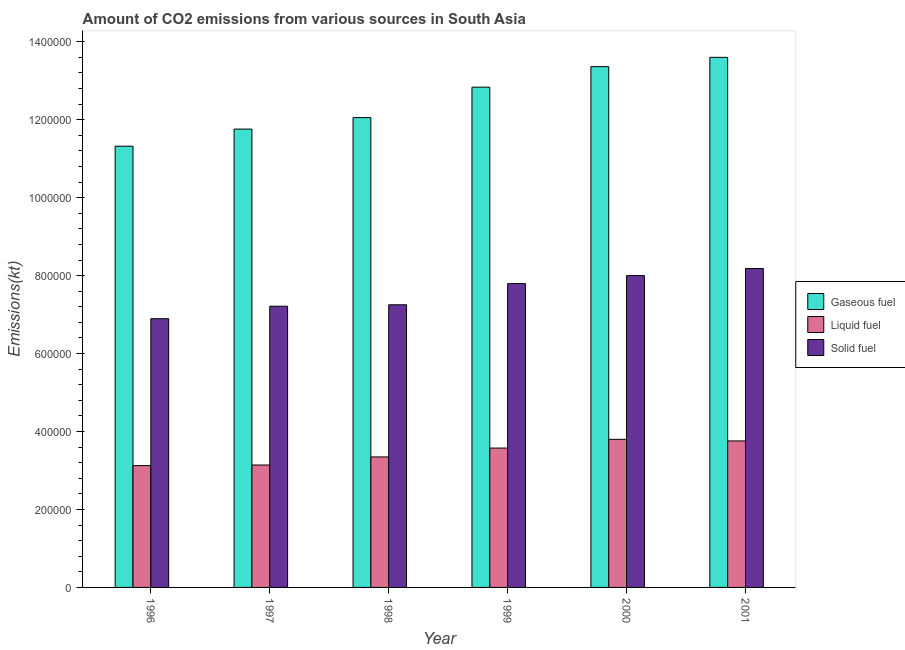How many different coloured bars are there?
Provide a short and direct response. 3. How many groups of bars are there?
Your response must be concise. 6. Are the number of bars on each tick of the X-axis equal?
Ensure brevity in your answer.  Yes. How many bars are there on the 4th tick from the left?
Your answer should be very brief. 3. How many bars are there on the 6th tick from the right?
Offer a very short reply. 3. What is the amount of co2 emissions from solid fuel in 1996?
Ensure brevity in your answer.  6.90e+05. Across all years, what is the maximum amount of co2 emissions from solid fuel?
Make the answer very short. 8.18e+05. Across all years, what is the minimum amount of co2 emissions from solid fuel?
Provide a succinct answer. 6.90e+05. In which year was the amount of co2 emissions from gaseous fuel maximum?
Offer a very short reply. 2001. What is the total amount of co2 emissions from solid fuel in the graph?
Offer a terse response. 4.53e+06. What is the difference between the amount of co2 emissions from liquid fuel in 1996 and that in 2001?
Keep it short and to the point. -6.33e+04. What is the difference between the amount of co2 emissions from solid fuel in 2001 and the amount of co2 emissions from gaseous fuel in 1998?
Ensure brevity in your answer.  9.31e+04. What is the average amount of co2 emissions from solid fuel per year?
Offer a terse response. 7.56e+05. What is the ratio of the amount of co2 emissions from solid fuel in 1996 to that in 1997?
Keep it short and to the point. 0.96. Is the amount of co2 emissions from solid fuel in 1997 less than that in 1999?
Offer a terse response. Yes. Is the difference between the amount of co2 emissions from gaseous fuel in 1998 and 1999 greater than the difference between the amount of co2 emissions from solid fuel in 1998 and 1999?
Keep it short and to the point. No. What is the difference between the highest and the second highest amount of co2 emissions from liquid fuel?
Provide a short and direct response. 4092.37. What is the difference between the highest and the lowest amount of co2 emissions from solid fuel?
Your response must be concise. 1.29e+05. What does the 2nd bar from the left in 1997 represents?
Your response must be concise. Liquid fuel. What does the 2nd bar from the right in 1996 represents?
Your answer should be compact. Liquid fuel. How many years are there in the graph?
Keep it short and to the point. 6. Does the graph contain any zero values?
Provide a succinct answer. No. Does the graph contain grids?
Provide a succinct answer. No. Where does the legend appear in the graph?
Your answer should be compact. Center right. How are the legend labels stacked?
Keep it short and to the point. Vertical. What is the title of the graph?
Provide a succinct answer. Amount of CO2 emissions from various sources in South Asia. Does "Ages 20-50" appear as one of the legend labels in the graph?
Provide a succinct answer. No. What is the label or title of the Y-axis?
Offer a very short reply. Emissions(kt). What is the Emissions(kt) in Gaseous fuel in 1996?
Your answer should be very brief. 1.13e+06. What is the Emissions(kt) of Liquid fuel in 1996?
Provide a succinct answer. 3.13e+05. What is the Emissions(kt) in Solid fuel in 1996?
Offer a terse response. 6.90e+05. What is the Emissions(kt) of Gaseous fuel in 1997?
Offer a terse response. 1.18e+06. What is the Emissions(kt) in Liquid fuel in 1997?
Offer a very short reply. 3.14e+05. What is the Emissions(kt) of Solid fuel in 1997?
Ensure brevity in your answer.  7.22e+05. What is the Emissions(kt) in Gaseous fuel in 1998?
Make the answer very short. 1.21e+06. What is the Emissions(kt) of Liquid fuel in 1998?
Your response must be concise. 3.35e+05. What is the Emissions(kt) of Solid fuel in 1998?
Provide a succinct answer. 7.25e+05. What is the Emissions(kt) of Gaseous fuel in 1999?
Offer a terse response. 1.28e+06. What is the Emissions(kt) in Liquid fuel in 1999?
Offer a terse response. 3.58e+05. What is the Emissions(kt) in Solid fuel in 1999?
Provide a succinct answer. 7.79e+05. What is the Emissions(kt) of Gaseous fuel in 2000?
Offer a very short reply. 1.34e+06. What is the Emissions(kt) of Liquid fuel in 2000?
Give a very brief answer. 3.80e+05. What is the Emissions(kt) of Solid fuel in 2000?
Provide a short and direct response. 8.00e+05. What is the Emissions(kt) of Gaseous fuel in 2001?
Provide a succinct answer. 1.36e+06. What is the Emissions(kt) of Liquid fuel in 2001?
Your response must be concise. 3.76e+05. What is the Emissions(kt) in Solid fuel in 2001?
Make the answer very short. 8.18e+05. Across all years, what is the maximum Emissions(kt) in Gaseous fuel?
Your answer should be compact. 1.36e+06. Across all years, what is the maximum Emissions(kt) of Liquid fuel?
Your answer should be very brief. 3.80e+05. Across all years, what is the maximum Emissions(kt) of Solid fuel?
Your answer should be very brief. 8.18e+05. Across all years, what is the minimum Emissions(kt) in Gaseous fuel?
Give a very brief answer. 1.13e+06. Across all years, what is the minimum Emissions(kt) of Liquid fuel?
Provide a succinct answer. 3.13e+05. Across all years, what is the minimum Emissions(kt) of Solid fuel?
Your answer should be very brief. 6.90e+05. What is the total Emissions(kt) of Gaseous fuel in the graph?
Provide a succinct answer. 7.49e+06. What is the total Emissions(kt) of Liquid fuel in the graph?
Offer a terse response. 2.07e+06. What is the total Emissions(kt) of Solid fuel in the graph?
Your answer should be compact. 4.53e+06. What is the difference between the Emissions(kt) of Gaseous fuel in 1996 and that in 1997?
Ensure brevity in your answer.  -4.39e+04. What is the difference between the Emissions(kt) in Liquid fuel in 1996 and that in 1997?
Your answer should be very brief. -1547.47. What is the difference between the Emissions(kt) in Solid fuel in 1996 and that in 1997?
Make the answer very short. -3.20e+04. What is the difference between the Emissions(kt) in Gaseous fuel in 1996 and that in 1998?
Keep it short and to the point. -7.34e+04. What is the difference between the Emissions(kt) of Liquid fuel in 1996 and that in 1998?
Provide a succinct answer. -2.23e+04. What is the difference between the Emissions(kt) in Solid fuel in 1996 and that in 1998?
Your answer should be compact. -3.57e+04. What is the difference between the Emissions(kt) in Gaseous fuel in 1996 and that in 1999?
Provide a succinct answer. -1.51e+05. What is the difference between the Emissions(kt) in Liquid fuel in 1996 and that in 1999?
Offer a terse response. -4.50e+04. What is the difference between the Emissions(kt) in Solid fuel in 1996 and that in 1999?
Give a very brief answer. -9.00e+04. What is the difference between the Emissions(kt) in Gaseous fuel in 1996 and that in 2000?
Your answer should be very brief. -2.04e+05. What is the difference between the Emissions(kt) of Liquid fuel in 1996 and that in 2000?
Provide a succinct answer. -6.74e+04. What is the difference between the Emissions(kt) in Solid fuel in 1996 and that in 2000?
Give a very brief answer. -1.11e+05. What is the difference between the Emissions(kt) of Gaseous fuel in 1996 and that in 2001?
Your response must be concise. -2.28e+05. What is the difference between the Emissions(kt) of Liquid fuel in 1996 and that in 2001?
Your answer should be very brief. -6.33e+04. What is the difference between the Emissions(kt) in Solid fuel in 1996 and that in 2001?
Provide a succinct answer. -1.29e+05. What is the difference between the Emissions(kt) of Gaseous fuel in 1997 and that in 1998?
Offer a terse response. -2.95e+04. What is the difference between the Emissions(kt) of Liquid fuel in 1997 and that in 1998?
Provide a succinct answer. -2.07e+04. What is the difference between the Emissions(kt) of Solid fuel in 1997 and that in 1998?
Offer a terse response. -3677.84. What is the difference between the Emissions(kt) in Gaseous fuel in 1997 and that in 1999?
Your response must be concise. -1.08e+05. What is the difference between the Emissions(kt) in Liquid fuel in 1997 and that in 1999?
Your answer should be very brief. -4.35e+04. What is the difference between the Emissions(kt) in Solid fuel in 1997 and that in 1999?
Keep it short and to the point. -5.80e+04. What is the difference between the Emissions(kt) of Gaseous fuel in 1997 and that in 2000?
Your answer should be compact. -1.60e+05. What is the difference between the Emissions(kt) in Liquid fuel in 1997 and that in 2000?
Make the answer very short. -6.59e+04. What is the difference between the Emissions(kt) of Solid fuel in 1997 and that in 2000?
Make the answer very short. -7.85e+04. What is the difference between the Emissions(kt) in Gaseous fuel in 1997 and that in 2001?
Provide a succinct answer. -1.84e+05. What is the difference between the Emissions(kt) of Liquid fuel in 1997 and that in 2001?
Provide a short and direct response. -6.18e+04. What is the difference between the Emissions(kt) in Solid fuel in 1997 and that in 2001?
Give a very brief answer. -9.68e+04. What is the difference between the Emissions(kt) in Gaseous fuel in 1998 and that in 1999?
Ensure brevity in your answer.  -7.81e+04. What is the difference between the Emissions(kt) in Liquid fuel in 1998 and that in 1999?
Offer a terse response. -2.27e+04. What is the difference between the Emissions(kt) of Solid fuel in 1998 and that in 1999?
Give a very brief answer. -5.43e+04. What is the difference between the Emissions(kt) of Gaseous fuel in 1998 and that in 2000?
Ensure brevity in your answer.  -1.31e+05. What is the difference between the Emissions(kt) in Liquid fuel in 1998 and that in 2000?
Make the answer very short. -4.51e+04. What is the difference between the Emissions(kt) in Solid fuel in 1998 and that in 2000?
Keep it short and to the point. -7.49e+04. What is the difference between the Emissions(kt) in Gaseous fuel in 1998 and that in 2001?
Offer a very short reply. -1.55e+05. What is the difference between the Emissions(kt) of Liquid fuel in 1998 and that in 2001?
Ensure brevity in your answer.  -4.10e+04. What is the difference between the Emissions(kt) of Solid fuel in 1998 and that in 2001?
Your answer should be very brief. -9.31e+04. What is the difference between the Emissions(kt) in Gaseous fuel in 1999 and that in 2000?
Ensure brevity in your answer.  -5.26e+04. What is the difference between the Emissions(kt) in Liquid fuel in 1999 and that in 2000?
Your answer should be very brief. -2.24e+04. What is the difference between the Emissions(kt) of Solid fuel in 1999 and that in 2000?
Offer a very short reply. -2.06e+04. What is the difference between the Emissions(kt) of Gaseous fuel in 1999 and that in 2001?
Your answer should be very brief. -7.66e+04. What is the difference between the Emissions(kt) in Liquid fuel in 1999 and that in 2001?
Provide a short and direct response. -1.83e+04. What is the difference between the Emissions(kt) of Solid fuel in 1999 and that in 2001?
Provide a succinct answer. -3.88e+04. What is the difference between the Emissions(kt) in Gaseous fuel in 2000 and that in 2001?
Your answer should be very brief. -2.40e+04. What is the difference between the Emissions(kt) in Liquid fuel in 2000 and that in 2001?
Provide a succinct answer. 4092.37. What is the difference between the Emissions(kt) in Solid fuel in 2000 and that in 2001?
Offer a very short reply. -1.82e+04. What is the difference between the Emissions(kt) in Gaseous fuel in 1996 and the Emissions(kt) in Liquid fuel in 1997?
Provide a short and direct response. 8.18e+05. What is the difference between the Emissions(kt) in Gaseous fuel in 1996 and the Emissions(kt) in Solid fuel in 1997?
Give a very brief answer. 4.11e+05. What is the difference between the Emissions(kt) of Liquid fuel in 1996 and the Emissions(kt) of Solid fuel in 1997?
Keep it short and to the point. -4.09e+05. What is the difference between the Emissions(kt) in Gaseous fuel in 1996 and the Emissions(kt) in Liquid fuel in 1998?
Offer a terse response. 7.97e+05. What is the difference between the Emissions(kt) in Gaseous fuel in 1996 and the Emissions(kt) in Solid fuel in 1998?
Offer a very short reply. 4.07e+05. What is the difference between the Emissions(kt) of Liquid fuel in 1996 and the Emissions(kt) of Solid fuel in 1998?
Ensure brevity in your answer.  -4.13e+05. What is the difference between the Emissions(kt) of Gaseous fuel in 1996 and the Emissions(kt) of Liquid fuel in 1999?
Give a very brief answer. 7.75e+05. What is the difference between the Emissions(kt) in Gaseous fuel in 1996 and the Emissions(kt) in Solid fuel in 1999?
Give a very brief answer. 3.53e+05. What is the difference between the Emissions(kt) in Liquid fuel in 1996 and the Emissions(kt) in Solid fuel in 1999?
Offer a very short reply. -4.67e+05. What is the difference between the Emissions(kt) in Gaseous fuel in 1996 and the Emissions(kt) in Liquid fuel in 2000?
Offer a terse response. 7.52e+05. What is the difference between the Emissions(kt) of Gaseous fuel in 1996 and the Emissions(kt) of Solid fuel in 2000?
Offer a very short reply. 3.32e+05. What is the difference between the Emissions(kt) in Liquid fuel in 1996 and the Emissions(kt) in Solid fuel in 2000?
Make the answer very short. -4.88e+05. What is the difference between the Emissions(kt) in Gaseous fuel in 1996 and the Emissions(kt) in Liquid fuel in 2001?
Your answer should be very brief. 7.56e+05. What is the difference between the Emissions(kt) of Gaseous fuel in 1996 and the Emissions(kt) of Solid fuel in 2001?
Your answer should be very brief. 3.14e+05. What is the difference between the Emissions(kt) of Liquid fuel in 1996 and the Emissions(kt) of Solid fuel in 2001?
Provide a short and direct response. -5.06e+05. What is the difference between the Emissions(kt) of Gaseous fuel in 1997 and the Emissions(kt) of Liquid fuel in 1998?
Provide a short and direct response. 8.41e+05. What is the difference between the Emissions(kt) of Gaseous fuel in 1997 and the Emissions(kt) of Solid fuel in 1998?
Ensure brevity in your answer.  4.51e+05. What is the difference between the Emissions(kt) of Liquid fuel in 1997 and the Emissions(kt) of Solid fuel in 1998?
Provide a short and direct response. -4.11e+05. What is the difference between the Emissions(kt) in Gaseous fuel in 1997 and the Emissions(kt) in Liquid fuel in 1999?
Offer a terse response. 8.18e+05. What is the difference between the Emissions(kt) of Gaseous fuel in 1997 and the Emissions(kt) of Solid fuel in 1999?
Your answer should be very brief. 3.97e+05. What is the difference between the Emissions(kt) in Liquid fuel in 1997 and the Emissions(kt) in Solid fuel in 1999?
Your answer should be compact. -4.65e+05. What is the difference between the Emissions(kt) in Gaseous fuel in 1997 and the Emissions(kt) in Liquid fuel in 2000?
Your answer should be compact. 7.96e+05. What is the difference between the Emissions(kt) of Gaseous fuel in 1997 and the Emissions(kt) of Solid fuel in 2000?
Ensure brevity in your answer.  3.76e+05. What is the difference between the Emissions(kt) in Liquid fuel in 1997 and the Emissions(kt) in Solid fuel in 2000?
Provide a short and direct response. -4.86e+05. What is the difference between the Emissions(kt) of Gaseous fuel in 1997 and the Emissions(kt) of Liquid fuel in 2001?
Give a very brief answer. 8.00e+05. What is the difference between the Emissions(kt) in Gaseous fuel in 1997 and the Emissions(kt) in Solid fuel in 2001?
Your response must be concise. 3.58e+05. What is the difference between the Emissions(kt) of Liquid fuel in 1997 and the Emissions(kt) of Solid fuel in 2001?
Provide a succinct answer. -5.04e+05. What is the difference between the Emissions(kt) in Gaseous fuel in 1998 and the Emissions(kt) in Liquid fuel in 1999?
Make the answer very short. 8.48e+05. What is the difference between the Emissions(kt) in Gaseous fuel in 1998 and the Emissions(kt) in Solid fuel in 1999?
Your response must be concise. 4.26e+05. What is the difference between the Emissions(kt) in Liquid fuel in 1998 and the Emissions(kt) in Solid fuel in 1999?
Ensure brevity in your answer.  -4.45e+05. What is the difference between the Emissions(kt) in Gaseous fuel in 1998 and the Emissions(kt) in Liquid fuel in 2000?
Provide a succinct answer. 8.26e+05. What is the difference between the Emissions(kt) of Gaseous fuel in 1998 and the Emissions(kt) of Solid fuel in 2000?
Keep it short and to the point. 4.05e+05. What is the difference between the Emissions(kt) in Liquid fuel in 1998 and the Emissions(kt) in Solid fuel in 2000?
Your answer should be compact. -4.65e+05. What is the difference between the Emissions(kt) in Gaseous fuel in 1998 and the Emissions(kt) in Liquid fuel in 2001?
Provide a succinct answer. 8.30e+05. What is the difference between the Emissions(kt) in Gaseous fuel in 1998 and the Emissions(kt) in Solid fuel in 2001?
Keep it short and to the point. 3.87e+05. What is the difference between the Emissions(kt) in Liquid fuel in 1998 and the Emissions(kt) in Solid fuel in 2001?
Make the answer very short. -4.83e+05. What is the difference between the Emissions(kt) in Gaseous fuel in 1999 and the Emissions(kt) in Liquid fuel in 2000?
Your answer should be compact. 9.04e+05. What is the difference between the Emissions(kt) in Gaseous fuel in 1999 and the Emissions(kt) in Solid fuel in 2000?
Keep it short and to the point. 4.83e+05. What is the difference between the Emissions(kt) of Liquid fuel in 1999 and the Emissions(kt) of Solid fuel in 2000?
Offer a very short reply. -4.42e+05. What is the difference between the Emissions(kt) in Gaseous fuel in 1999 and the Emissions(kt) in Liquid fuel in 2001?
Give a very brief answer. 9.08e+05. What is the difference between the Emissions(kt) of Gaseous fuel in 1999 and the Emissions(kt) of Solid fuel in 2001?
Provide a short and direct response. 4.65e+05. What is the difference between the Emissions(kt) in Liquid fuel in 1999 and the Emissions(kt) in Solid fuel in 2001?
Your answer should be compact. -4.61e+05. What is the difference between the Emissions(kt) of Gaseous fuel in 2000 and the Emissions(kt) of Liquid fuel in 2001?
Offer a terse response. 9.60e+05. What is the difference between the Emissions(kt) in Gaseous fuel in 2000 and the Emissions(kt) in Solid fuel in 2001?
Keep it short and to the point. 5.18e+05. What is the difference between the Emissions(kt) of Liquid fuel in 2000 and the Emissions(kt) of Solid fuel in 2001?
Ensure brevity in your answer.  -4.38e+05. What is the average Emissions(kt) in Gaseous fuel per year?
Your answer should be compact. 1.25e+06. What is the average Emissions(kt) in Liquid fuel per year?
Offer a very short reply. 3.46e+05. What is the average Emissions(kt) of Solid fuel per year?
Give a very brief answer. 7.56e+05. In the year 1996, what is the difference between the Emissions(kt) of Gaseous fuel and Emissions(kt) of Liquid fuel?
Give a very brief answer. 8.20e+05. In the year 1996, what is the difference between the Emissions(kt) of Gaseous fuel and Emissions(kt) of Solid fuel?
Provide a short and direct response. 4.43e+05. In the year 1996, what is the difference between the Emissions(kt) of Liquid fuel and Emissions(kt) of Solid fuel?
Ensure brevity in your answer.  -3.77e+05. In the year 1997, what is the difference between the Emissions(kt) in Gaseous fuel and Emissions(kt) in Liquid fuel?
Make the answer very short. 8.62e+05. In the year 1997, what is the difference between the Emissions(kt) in Gaseous fuel and Emissions(kt) in Solid fuel?
Ensure brevity in your answer.  4.54e+05. In the year 1997, what is the difference between the Emissions(kt) in Liquid fuel and Emissions(kt) in Solid fuel?
Provide a succinct answer. -4.07e+05. In the year 1998, what is the difference between the Emissions(kt) in Gaseous fuel and Emissions(kt) in Liquid fuel?
Provide a succinct answer. 8.71e+05. In the year 1998, what is the difference between the Emissions(kt) in Gaseous fuel and Emissions(kt) in Solid fuel?
Make the answer very short. 4.80e+05. In the year 1998, what is the difference between the Emissions(kt) of Liquid fuel and Emissions(kt) of Solid fuel?
Offer a terse response. -3.90e+05. In the year 1999, what is the difference between the Emissions(kt) of Gaseous fuel and Emissions(kt) of Liquid fuel?
Give a very brief answer. 9.26e+05. In the year 1999, what is the difference between the Emissions(kt) of Gaseous fuel and Emissions(kt) of Solid fuel?
Your answer should be very brief. 5.04e+05. In the year 1999, what is the difference between the Emissions(kt) of Liquid fuel and Emissions(kt) of Solid fuel?
Ensure brevity in your answer.  -4.22e+05. In the year 2000, what is the difference between the Emissions(kt) of Gaseous fuel and Emissions(kt) of Liquid fuel?
Offer a terse response. 9.56e+05. In the year 2000, what is the difference between the Emissions(kt) of Gaseous fuel and Emissions(kt) of Solid fuel?
Provide a short and direct response. 5.36e+05. In the year 2000, what is the difference between the Emissions(kt) in Liquid fuel and Emissions(kt) in Solid fuel?
Provide a succinct answer. -4.20e+05. In the year 2001, what is the difference between the Emissions(kt) in Gaseous fuel and Emissions(kt) in Liquid fuel?
Offer a very short reply. 9.84e+05. In the year 2001, what is the difference between the Emissions(kt) in Gaseous fuel and Emissions(kt) in Solid fuel?
Your answer should be compact. 5.42e+05. In the year 2001, what is the difference between the Emissions(kt) in Liquid fuel and Emissions(kt) in Solid fuel?
Provide a succinct answer. -4.42e+05. What is the ratio of the Emissions(kt) of Gaseous fuel in 1996 to that in 1997?
Offer a terse response. 0.96. What is the ratio of the Emissions(kt) in Solid fuel in 1996 to that in 1997?
Keep it short and to the point. 0.96. What is the ratio of the Emissions(kt) in Gaseous fuel in 1996 to that in 1998?
Offer a terse response. 0.94. What is the ratio of the Emissions(kt) of Liquid fuel in 1996 to that in 1998?
Your answer should be compact. 0.93. What is the ratio of the Emissions(kt) of Solid fuel in 1996 to that in 1998?
Give a very brief answer. 0.95. What is the ratio of the Emissions(kt) in Gaseous fuel in 1996 to that in 1999?
Ensure brevity in your answer.  0.88. What is the ratio of the Emissions(kt) in Liquid fuel in 1996 to that in 1999?
Offer a very short reply. 0.87. What is the ratio of the Emissions(kt) of Solid fuel in 1996 to that in 1999?
Keep it short and to the point. 0.88. What is the ratio of the Emissions(kt) in Gaseous fuel in 1996 to that in 2000?
Provide a short and direct response. 0.85. What is the ratio of the Emissions(kt) of Liquid fuel in 1996 to that in 2000?
Your response must be concise. 0.82. What is the ratio of the Emissions(kt) in Solid fuel in 1996 to that in 2000?
Keep it short and to the point. 0.86. What is the ratio of the Emissions(kt) in Gaseous fuel in 1996 to that in 2001?
Offer a terse response. 0.83. What is the ratio of the Emissions(kt) in Liquid fuel in 1996 to that in 2001?
Your response must be concise. 0.83. What is the ratio of the Emissions(kt) in Solid fuel in 1996 to that in 2001?
Keep it short and to the point. 0.84. What is the ratio of the Emissions(kt) of Gaseous fuel in 1997 to that in 1998?
Make the answer very short. 0.98. What is the ratio of the Emissions(kt) of Liquid fuel in 1997 to that in 1998?
Provide a short and direct response. 0.94. What is the ratio of the Emissions(kt) of Solid fuel in 1997 to that in 1998?
Ensure brevity in your answer.  0.99. What is the ratio of the Emissions(kt) in Gaseous fuel in 1997 to that in 1999?
Your answer should be compact. 0.92. What is the ratio of the Emissions(kt) in Liquid fuel in 1997 to that in 1999?
Keep it short and to the point. 0.88. What is the ratio of the Emissions(kt) of Solid fuel in 1997 to that in 1999?
Provide a short and direct response. 0.93. What is the ratio of the Emissions(kt) in Gaseous fuel in 1997 to that in 2000?
Make the answer very short. 0.88. What is the ratio of the Emissions(kt) in Liquid fuel in 1997 to that in 2000?
Offer a very short reply. 0.83. What is the ratio of the Emissions(kt) of Solid fuel in 1997 to that in 2000?
Make the answer very short. 0.9. What is the ratio of the Emissions(kt) of Gaseous fuel in 1997 to that in 2001?
Your answer should be very brief. 0.86. What is the ratio of the Emissions(kt) of Liquid fuel in 1997 to that in 2001?
Offer a terse response. 0.84. What is the ratio of the Emissions(kt) of Solid fuel in 1997 to that in 2001?
Provide a succinct answer. 0.88. What is the ratio of the Emissions(kt) of Gaseous fuel in 1998 to that in 1999?
Provide a short and direct response. 0.94. What is the ratio of the Emissions(kt) in Liquid fuel in 1998 to that in 1999?
Provide a succinct answer. 0.94. What is the ratio of the Emissions(kt) in Solid fuel in 1998 to that in 1999?
Provide a succinct answer. 0.93. What is the ratio of the Emissions(kt) of Gaseous fuel in 1998 to that in 2000?
Make the answer very short. 0.9. What is the ratio of the Emissions(kt) of Liquid fuel in 1998 to that in 2000?
Keep it short and to the point. 0.88. What is the ratio of the Emissions(kt) of Solid fuel in 1998 to that in 2000?
Your answer should be compact. 0.91. What is the ratio of the Emissions(kt) of Gaseous fuel in 1998 to that in 2001?
Provide a short and direct response. 0.89. What is the ratio of the Emissions(kt) of Liquid fuel in 1998 to that in 2001?
Provide a succinct answer. 0.89. What is the ratio of the Emissions(kt) in Solid fuel in 1998 to that in 2001?
Your answer should be very brief. 0.89. What is the ratio of the Emissions(kt) of Gaseous fuel in 1999 to that in 2000?
Your answer should be compact. 0.96. What is the ratio of the Emissions(kt) in Liquid fuel in 1999 to that in 2000?
Ensure brevity in your answer.  0.94. What is the ratio of the Emissions(kt) in Solid fuel in 1999 to that in 2000?
Give a very brief answer. 0.97. What is the ratio of the Emissions(kt) in Gaseous fuel in 1999 to that in 2001?
Keep it short and to the point. 0.94. What is the ratio of the Emissions(kt) in Liquid fuel in 1999 to that in 2001?
Your answer should be very brief. 0.95. What is the ratio of the Emissions(kt) in Solid fuel in 1999 to that in 2001?
Offer a very short reply. 0.95. What is the ratio of the Emissions(kt) in Gaseous fuel in 2000 to that in 2001?
Your answer should be compact. 0.98. What is the ratio of the Emissions(kt) of Liquid fuel in 2000 to that in 2001?
Give a very brief answer. 1.01. What is the ratio of the Emissions(kt) of Solid fuel in 2000 to that in 2001?
Your response must be concise. 0.98. What is the difference between the highest and the second highest Emissions(kt) of Gaseous fuel?
Provide a succinct answer. 2.40e+04. What is the difference between the highest and the second highest Emissions(kt) of Liquid fuel?
Provide a succinct answer. 4092.37. What is the difference between the highest and the second highest Emissions(kt) in Solid fuel?
Give a very brief answer. 1.82e+04. What is the difference between the highest and the lowest Emissions(kt) in Gaseous fuel?
Offer a terse response. 2.28e+05. What is the difference between the highest and the lowest Emissions(kt) in Liquid fuel?
Give a very brief answer. 6.74e+04. What is the difference between the highest and the lowest Emissions(kt) of Solid fuel?
Your response must be concise. 1.29e+05. 